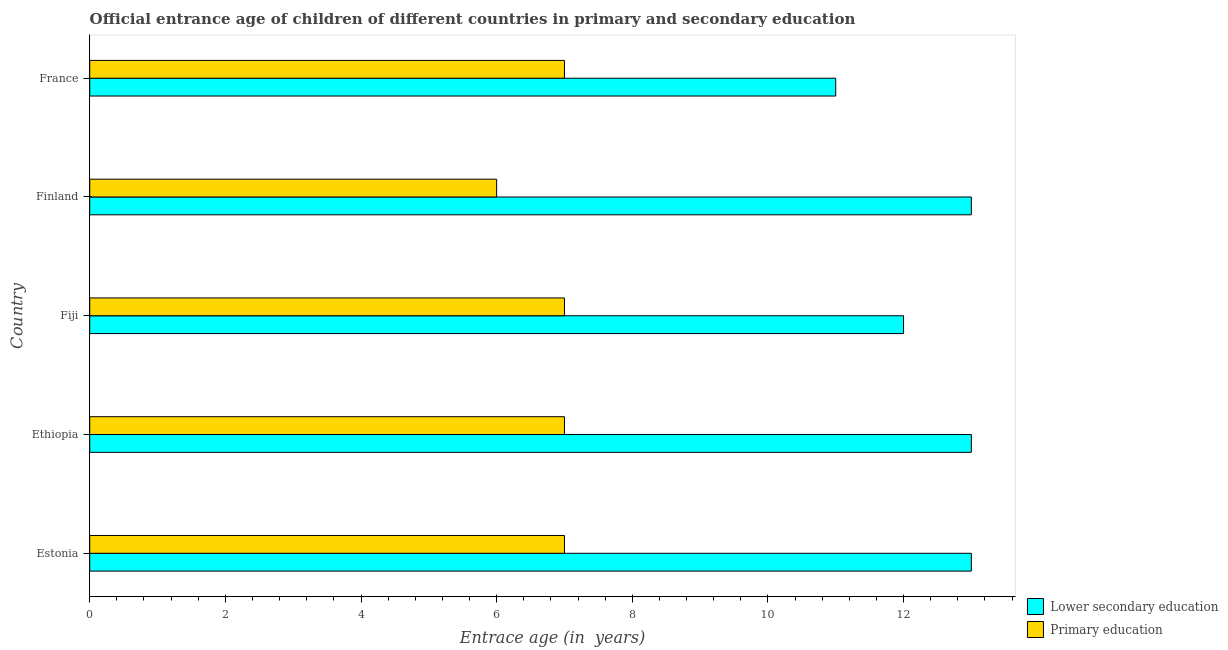How many different coloured bars are there?
Offer a very short reply. 2. Are the number of bars per tick equal to the number of legend labels?
Offer a terse response. Yes. Are the number of bars on each tick of the Y-axis equal?
Give a very brief answer. Yes. What is the label of the 5th group of bars from the top?
Your response must be concise. Estonia. In how many cases, is the number of bars for a given country not equal to the number of legend labels?
Keep it short and to the point. 0. What is the entrance age of children in lower secondary education in Estonia?
Your response must be concise. 13. Across all countries, what is the maximum entrance age of children in lower secondary education?
Your response must be concise. 13. Across all countries, what is the minimum entrance age of chiildren in primary education?
Ensure brevity in your answer.  6. In which country was the entrance age of chiildren in primary education maximum?
Offer a terse response. Estonia. What is the total entrance age of chiildren in primary education in the graph?
Offer a terse response. 34. What is the difference between the entrance age of children in lower secondary education in Finland and that in France?
Make the answer very short. 2. What is the difference between the entrance age of children in lower secondary education in Estonia and the entrance age of chiildren in primary education in Ethiopia?
Give a very brief answer. 6. What is the average entrance age of children in lower secondary education per country?
Offer a terse response. 12.4. What is the difference between the entrance age of chiildren in primary education and entrance age of children in lower secondary education in Finland?
Your answer should be very brief. -7. What is the ratio of the entrance age of chiildren in primary education in Estonia to that in Finland?
Ensure brevity in your answer.  1.17. Is the difference between the entrance age of chiildren in primary education in Fiji and France greater than the difference between the entrance age of children in lower secondary education in Fiji and France?
Keep it short and to the point. No. What is the difference between the highest and the lowest entrance age of children in lower secondary education?
Make the answer very short. 2. In how many countries, is the entrance age of children in lower secondary education greater than the average entrance age of children in lower secondary education taken over all countries?
Give a very brief answer. 3. What does the 2nd bar from the top in Estonia represents?
Make the answer very short. Lower secondary education. What does the 2nd bar from the bottom in Ethiopia represents?
Offer a very short reply. Primary education. How many bars are there?
Ensure brevity in your answer.  10. What is the difference between two consecutive major ticks on the X-axis?
Offer a terse response. 2. Does the graph contain grids?
Ensure brevity in your answer.  No. Where does the legend appear in the graph?
Offer a very short reply. Bottom right. How many legend labels are there?
Make the answer very short. 2. What is the title of the graph?
Ensure brevity in your answer.  Official entrance age of children of different countries in primary and secondary education. Does "Exports" appear as one of the legend labels in the graph?
Provide a short and direct response. No. What is the label or title of the X-axis?
Give a very brief answer. Entrace age (in  years). What is the Entrace age (in  years) of Lower secondary education in Fiji?
Give a very brief answer. 12. What is the Entrace age (in  years) of Primary education in Fiji?
Provide a short and direct response. 7. What is the Entrace age (in  years) in Primary education in Finland?
Provide a succinct answer. 6. What is the Entrace age (in  years) of Lower secondary education in France?
Make the answer very short. 11. What is the Entrace age (in  years) of Primary education in France?
Your response must be concise. 7. Across all countries, what is the maximum Entrace age (in  years) of Lower secondary education?
Provide a succinct answer. 13. Across all countries, what is the maximum Entrace age (in  years) in Primary education?
Offer a very short reply. 7. Across all countries, what is the minimum Entrace age (in  years) in Lower secondary education?
Give a very brief answer. 11. Across all countries, what is the minimum Entrace age (in  years) of Primary education?
Make the answer very short. 6. What is the total Entrace age (in  years) in Primary education in the graph?
Your answer should be compact. 34. What is the difference between the Entrace age (in  years) of Lower secondary education in Estonia and that in Ethiopia?
Your response must be concise. 0. What is the difference between the Entrace age (in  years) in Primary education in Estonia and that in Ethiopia?
Offer a terse response. 0. What is the difference between the Entrace age (in  years) of Lower secondary education in Estonia and that in Fiji?
Provide a short and direct response. 1. What is the difference between the Entrace age (in  years) in Lower secondary education in Estonia and that in Finland?
Your answer should be very brief. 0. What is the difference between the Entrace age (in  years) in Primary education in Estonia and that in France?
Offer a very short reply. 0. What is the difference between the Entrace age (in  years) of Primary education in Ethiopia and that in Fiji?
Ensure brevity in your answer.  0. What is the difference between the Entrace age (in  years) in Primary education in Ethiopia and that in Finland?
Your answer should be very brief. 1. What is the difference between the Entrace age (in  years) of Lower secondary education in Fiji and that in Finland?
Give a very brief answer. -1. What is the difference between the Entrace age (in  years) in Primary education in Fiji and that in Finland?
Provide a succinct answer. 1. What is the difference between the Entrace age (in  years) of Primary education in Fiji and that in France?
Keep it short and to the point. 0. What is the difference between the Entrace age (in  years) in Lower secondary education in Finland and that in France?
Your answer should be compact. 2. What is the difference between the Entrace age (in  years) in Primary education in Finland and that in France?
Your response must be concise. -1. What is the difference between the Entrace age (in  years) of Lower secondary education in Estonia and the Entrace age (in  years) of Primary education in Ethiopia?
Make the answer very short. 6. What is the difference between the Entrace age (in  years) in Lower secondary education in Estonia and the Entrace age (in  years) in Primary education in Fiji?
Keep it short and to the point. 6. What is the difference between the Entrace age (in  years) in Lower secondary education in Ethiopia and the Entrace age (in  years) in Primary education in Finland?
Offer a very short reply. 7. What is the difference between the Entrace age (in  years) of Lower secondary education in Fiji and the Entrace age (in  years) of Primary education in Finland?
Give a very brief answer. 6. What is the difference between the Entrace age (in  years) of Lower secondary education in Fiji and the Entrace age (in  years) of Primary education in France?
Your answer should be very brief. 5. What is the average Entrace age (in  years) in Lower secondary education per country?
Ensure brevity in your answer.  12.4. What is the difference between the Entrace age (in  years) in Lower secondary education and Entrace age (in  years) in Primary education in Ethiopia?
Provide a succinct answer. 6. What is the difference between the Entrace age (in  years) of Lower secondary education and Entrace age (in  years) of Primary education in Fiji?
Provide a succinct answer. 5. What is the difference between the Entrace age (in  years) of Lower secondary education and Entrace age (in  years) of Primary education in Finland?
Ensure brevity in your answer.  7. What is the ratio of the Entrace age (in  years) in Lower secondary education in Estonia to that in Ethiopia?
Provide a succinct answer. 1. What is the ratio of the Entrace age (in  years) in Primary education in Estonia to that in Ethiopia?
Your answer should be compact. 1. What is the ratio of the Entrace age (in  years) of Lower secondary education in Estonia to that in Finland?
Provide a succinct answer. 1. What is the ratio of the Entrace age (in  years) of Lower secondary education in Estonia to that in France?
Make the answer very short. 1.18. What is the ratio of the Entrace age (in  years) of Primary education in Ethiopia to that in Fiji?
Your answer should be compact. 1. What is the ratio of the Entrace age (in  years) in Primary education in Ethiopia to that in Finland?
Provide a short and direct response. 1.17. What is the ratio of the Entrace age (in  years) in Lower secondary education in Ethiopia to that in France?
Your answer should be compact. 1.18. What is the ratio of the Entrace age (in  years) of Primary education in Fiji to that in France?
Your response must be concise. 1. What is the ratio of the Entrace age (in  years) in Lower secondary education in Finland to that in France?
Make the answer very short. 1.18. What is the ratio of the Entrace age (in  years) in Primary education in Finland to that in France?
Make the answer very short. 0.86. What is the difference between the highest and the lowest Entrace age (in  years) in Lower secondary education?
Your answer should be compact. 2. What is the difference between the highest and the lowest Entrace age (in  years) of Primary education?
Give a very brief answer. 1. 